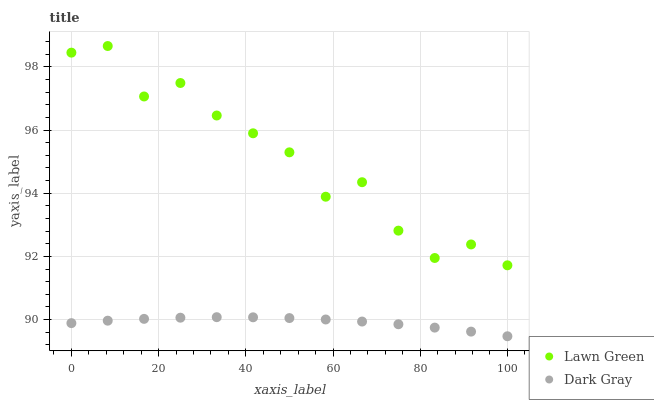Does Dark Gray have the minimum area under the curve?
Answer yes or no. Yes. Does Lawn Green have the maximum area under the curve?
Answer yes or no. Yes. Does Lawn Green have the minimum area under the curve?
Answer yes or no. No. Is Dark Gray the smoothest?
Answer yes or no. Yes. Is Lawn Green the roughest?
Answer yes or no. Yes. Is Lawn Green the smoothest?
Answer yes or no. No. Does Dark Gray have the lowest value?
Answer yes or no. Yes. Does Lawn Green have the lowest value?
Answer yes or no. No. Does Lawn Green have the highest value?
Answer yes or no. Yes. Is Dark Gray less than Lawn Green?
Answer yes or no. Yes. Is Lawn Green greater than Dark Gray?
Answer yes or no. Yes. Does Dark Gray intersect Lawn Green?
Answer yes or no. No. 